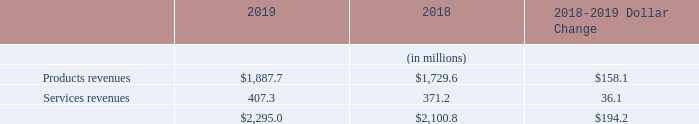The breakout of product and service revenues was as follows:
Our product revenues increased $158.1 million, or 9%, in 2019 from 2018 primarily due to higher sales in Semiconductor Test of testers for 5G infrastructure and image sensors, higher sales in Storage Test of 3.5” hard disk drive testers, and higher demand in Industrial Automation, partially offset by a decrease in sales in Semiconductor Test automotive and analog test segments. Service revenues increased $36.1 million or 10%.
In 2019 and 2018, no single direct customer accounted for more than 10% of our consolidated revenues. In 2019 and 2018, our five largest direct customers in aggregate accounted for 27% and 27% of our consolidated revenues, respectively.
We estimate consolidated revenues driven by Huawei Technologies Co. Ltd. (“Huawei”), combining direct sales to that customer with sales to the customer’s OSATs, accounted for approximately 11% and 4% of our consolidated revenues in 2019 and 2018, respectively. We estimate consolidated revenues driven by another OEM customer, combining direct sales to that customer with sales to the customer’s OSATs, accounted for approximately 10% and 13% of our consolidated revenues in 2019 and 2018, respectively.
What was the change in product revenues? $158.1 million. What was the change in services revenues? $36.1 million. What are the components comprising total revenue? Products revenues, services revenues. In which year was the amount of services revenues larger? 407.3>371.2
Answer: 2019. What was the percentage change in total revenues from 2018 to 2019?
Answer scale should be: percent. (2,295.0-2,100.8)/2,100.8
Answer: 9.24. What was the average services revenues in 2018 and 2019?
Answer scale should be: million. (407.3+371.2)/2
Answer: 389.25. 